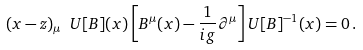Convert formula to latex. <formula><loc_0><loc_0><loc_500><loc_500>( x - z ) _ { \mu } \ U [ B ] ( x ) \left [ B ^ { \mu } ( x ) - { \frac { 1 } { i g } } \partial ^ { \mu } \right ] U [ B ] ^ { - 1 } ( x ) = 0 \, .</formula> 